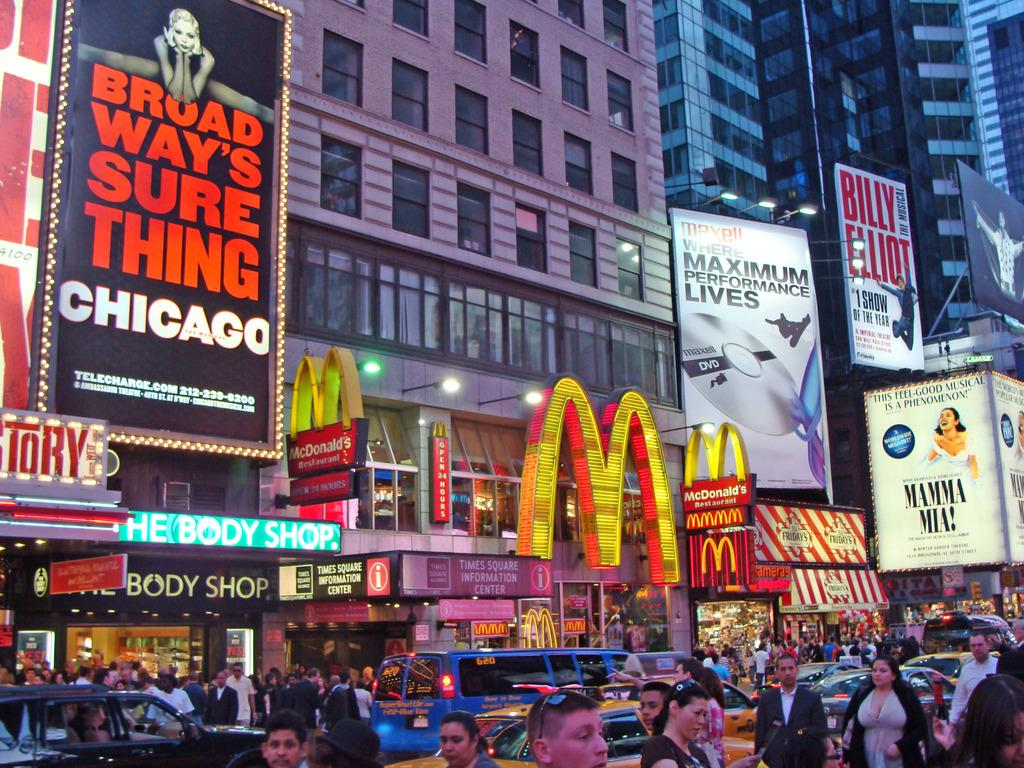Who or what is present in the image? There are people in the image. What can be seen on the road in the image? There are vehicles on the road in the image. What is visible in the background of the image? There are buildings, boards, lights, stores, and hoardings in the background of the image. What type of fiction is being read by the ducks in the image? There are no ducks present in the image, so it is not possible to determine what type of fiction they might be reading. 